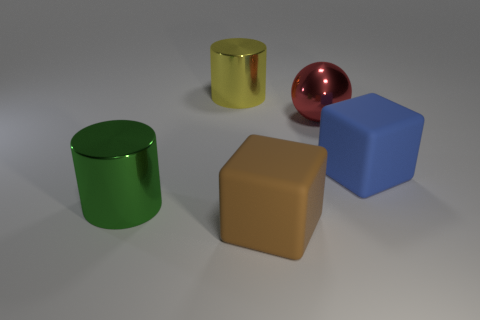Is the color of the rubber object behind the brown rubber block the same as the rubber block in front of the blue cube?
Keep it short and to the point. No. What number of things are either red metallic objects or blue rubber cubes?
Make the answer very short. 2. What number of other things are the same shape as the red object?
Make the answer very short. 0. Is the cylinder behind the large red metallic sphere made of the same material as the big object in front of the large green cylinder?
Make the answer very short. No. There is a large shiny object that is in front of the large yellow cylinder and to the left of the red sphere; what is its shape?
Your answer should be compact. Cylinder. Is there anything else that has the same material as the sphere?
Your answer should be very brief. Yes. What is the big thing that is on the left side of the big brown object and in front of the yellow metallic thing made of?
Provide a succinct answer. Metal. What is the shape of the large red object that is made of the same material as the yellow cylinder?
Your response must be concise. Sphere. Is there anything else that has the same color as the shiny sphere?
Make the answer very short. No. Is the number of large red metallic spheres to the left of the yellow cylinder greater than the number of big metal spheres?
Your response must be concise. No. 